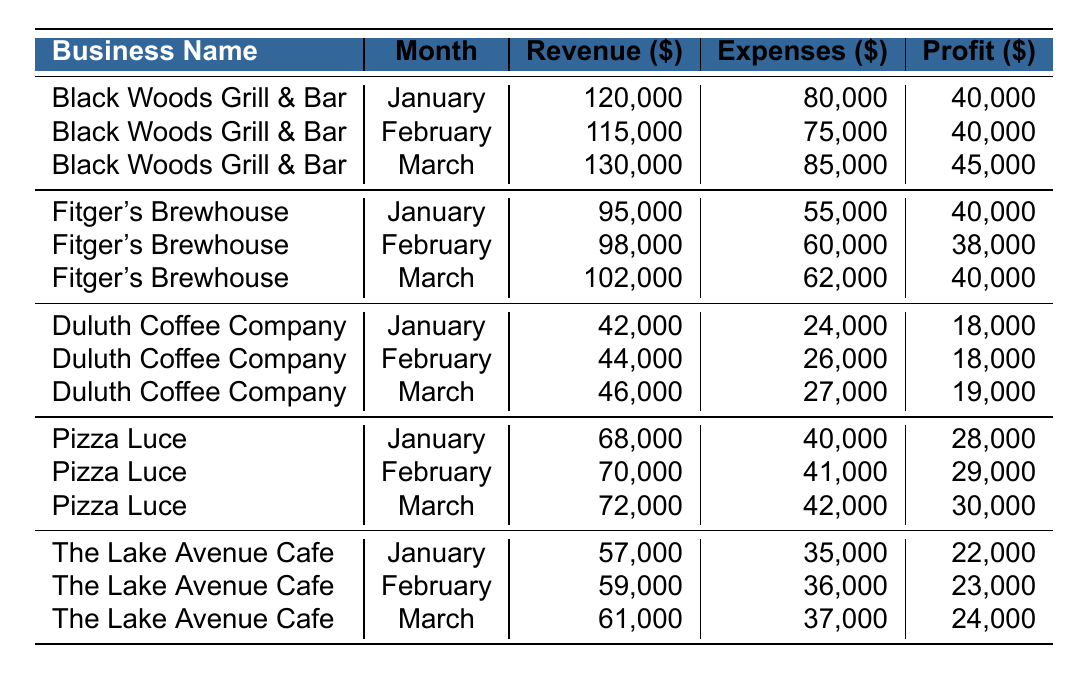What was the total revenue for Pizza Luce in March? The revenue for Pizza Luce in March is 72,000. This value can be found in the table under the specific month and business name.
Answer: 72,000 Which business had the highest profit in January? In January, Black Woods Grill & Bar and Fitger's Brewhouse both had a profit of 40,000, but Black Woods Grill & Bar had a higher revenue. Therefore, in terms of profit alone, they are tied.
Answer: Black Woods Grill & Bar and Fitger's Brewhouse (tie) What was the average profit for Duluth Coffee Company over the three months? The profits for Duluth Coffee Company over the three months are 18,000 (January), 18,000 (February), and 19,000 (March). Adding these gives 55,000. To find the average, divide by 3: 55,000 / 3 equals approximately 18,333.
Answer: 18,333 Did The Lake Avenue Cafe have a profit greater than 24,000 in any of the three months? The profits for The Lake Avenue Cafe were 22,000 in January, 23,000 in February, and 24,000 in March. It does not exceed 24,000 in any month.
Answer: No What is the total profit for all businesses combined in February? The profits in February are: Black Woods Grill & Bar (40,000), Fitger's Brewhouse (38,000), Duluth Coffee Company (18,000), Pizza Luce (29,000), and The Lake Avenue Cafe (23,000). Adding these gives 40,000 + 38,000 + 18,000 + 29,000 + 23,000 = 148,000.
Answer: 148,000 Which business showed the most consistent profit with the least variation over the three months? Analyzing the profits: Black Woods Grill & Bar ($40,000, $40,000, $45,000), Fitger's Brewhouse ($40,000, $38,000, $40,000), Duluth Coffee Company ($18,000, $18,000, $19,000), Pizza Luce ($28,000, $29,000, $30,000), and The Lake Avenue Cafe ($22,000, $23,000, $24,000). Focusing on the variability, Duluth Coffee Company has the least variation in profits; it only varies between $18,000 and $19,000.
Answer: Duluth Coffee Company What was the total expense incurred by the Black Woods Grill & Bar in the three months combined? The expenses for Black Woods Grill & Bar are 80,000 (January), 75,000 (February), and 85,000 (March). Adding these gives 80,000 + 75,000 + 85,000 = 240,000.
Answer: 240,000 